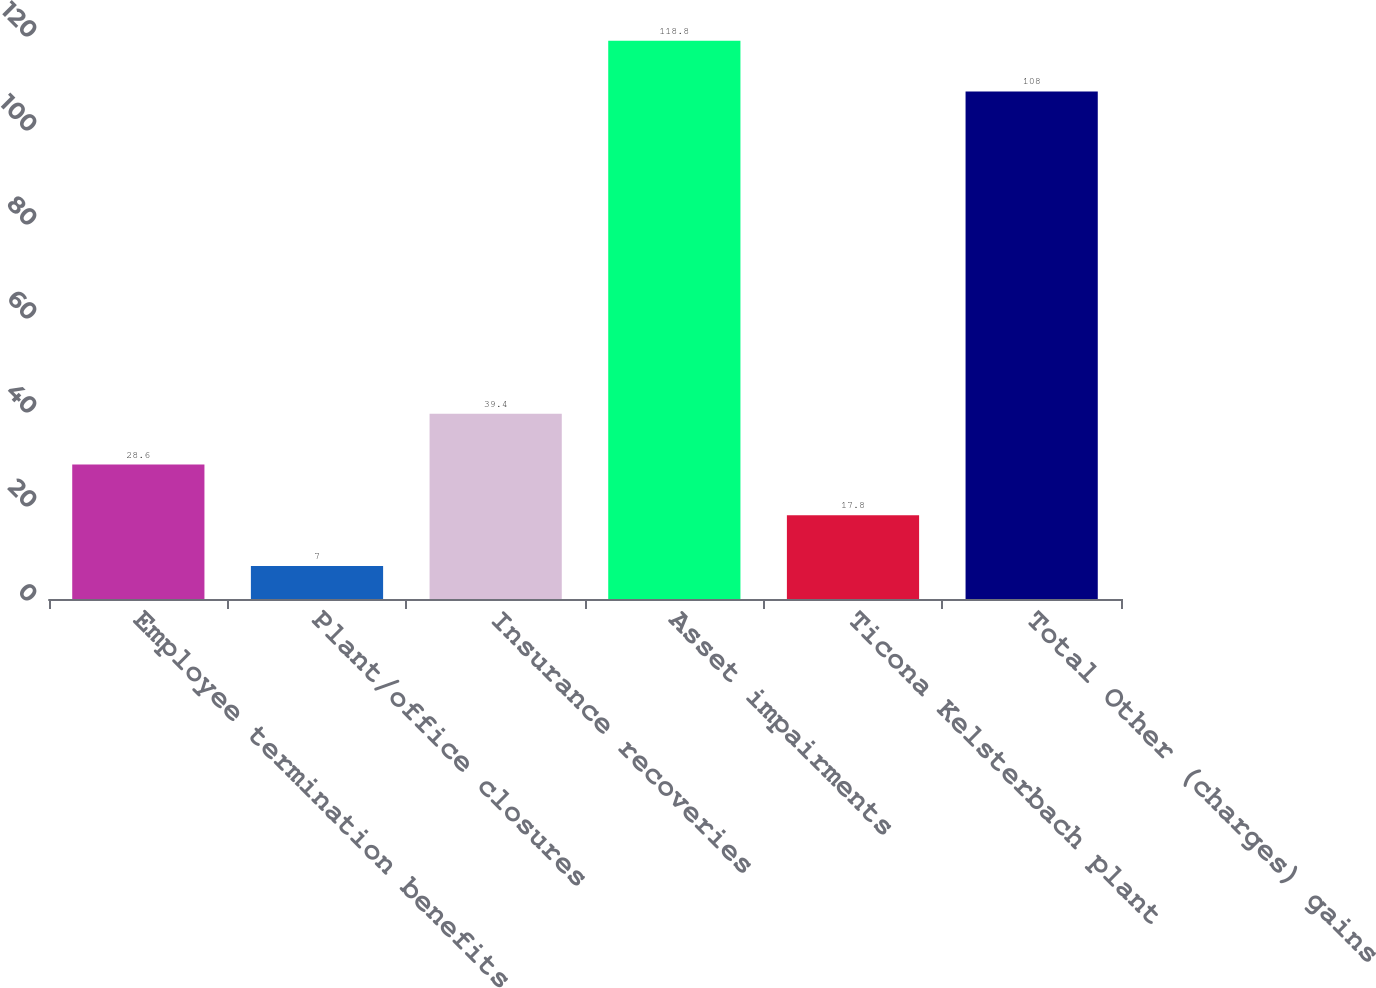Convert chart to OTSL. <chart><loc_0><loc_0><loc_500><loc_500><bar_chart><fcel>Employee termination benefits<fcel>Plant/office closures<fcel>Insurance recoveries<fcel>Asset impairments<fcel>Ticona Kelsterbach plant<fcel>Total Other (charges) gains<nl><fcel>28.6<fcel>7<fcel>39.4<fcel>118.8<fcel>17.8<fcel>108<nl></chart> 